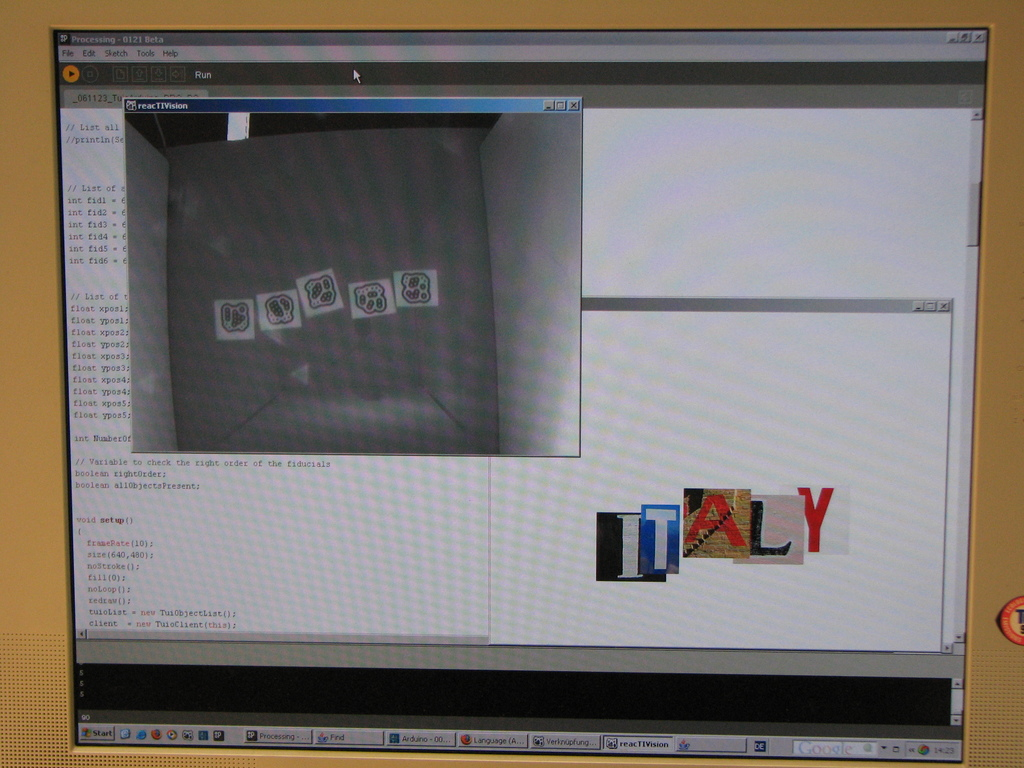Describe the creative elements seen in the right portion of the screen. The right portion of the screen displays a creatively assembled word 'ITALY', composed of images representing famous Italian landmarks overlaid with colors of the Italian flag, showcasing an innovative use of graphical editing to blend imagery and typography. What might be the purpose of combining these particular elements in the design? This design likely serves a dual purpose: first, to visually symbolize Italy through iconic imagery and national colors, and second, to possibly indicate a project theme or cultural context in a visually engaging manner, perhaps for educational or promotional uses. 